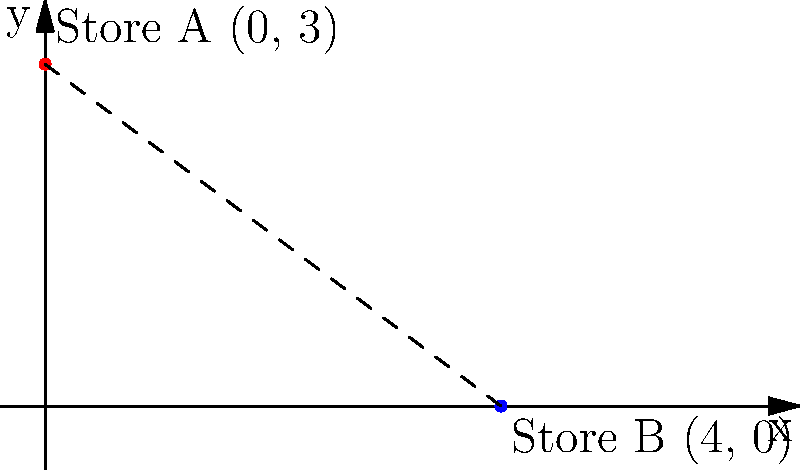Two vintage clothing stores, Store A and Store B, are located on a city grid. Store A is at coordinates (0, 3) and Store B is at coordinates (4, 0). Calculate the shortest distance between these two stores. To find the shortest distance between two points on a coordinate plane, we can use the distance formula, which is derived from the Pythagorean theorem:

Distance = $\sqrt{(x_2 - x_1)^2 + (y_2 - y_1)^2}$

Where $(x_1, y_1)$ are the coordinates of the first point and $(x_2, y_2)$ are the coordinates of the second point.

Let's solve this step by step:

1. Identify the coordinates:
   Store A: $(x_1, y_1) = (0, 3)$
   Store B: $(x_2, y_2) = (4, 0)$

2. Plug these values into the distance formula:
   Distance = $\sqrt{(4 - 0)^2 + (0 - 3)^2}$

3. Simplify the expressions inside the parentheses:
   Distance = $\sqrt{4^2 + (-3)^2}$

4. Calculate the squares:
   Distance = $\sqrt{16 + 9}$

5. Add the values under the square root:
   Distance = $\sqrt{25}$

6. Simplify the square root:
   Distance = 5

Therefore, the shortest distance between Store A and Store B is 5 units on the city grid.
Answer: 5 units 